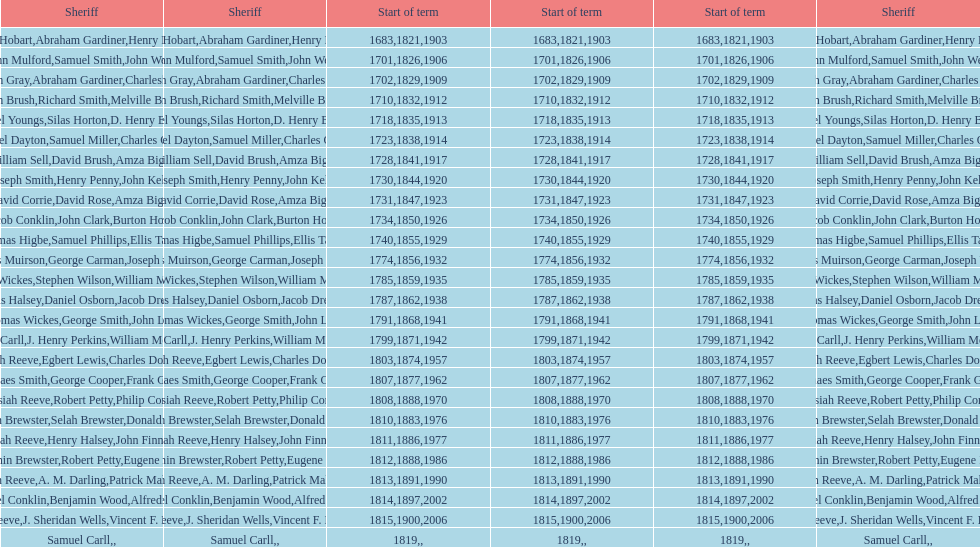What is the number of sheriff's with the last name smith? 5. 